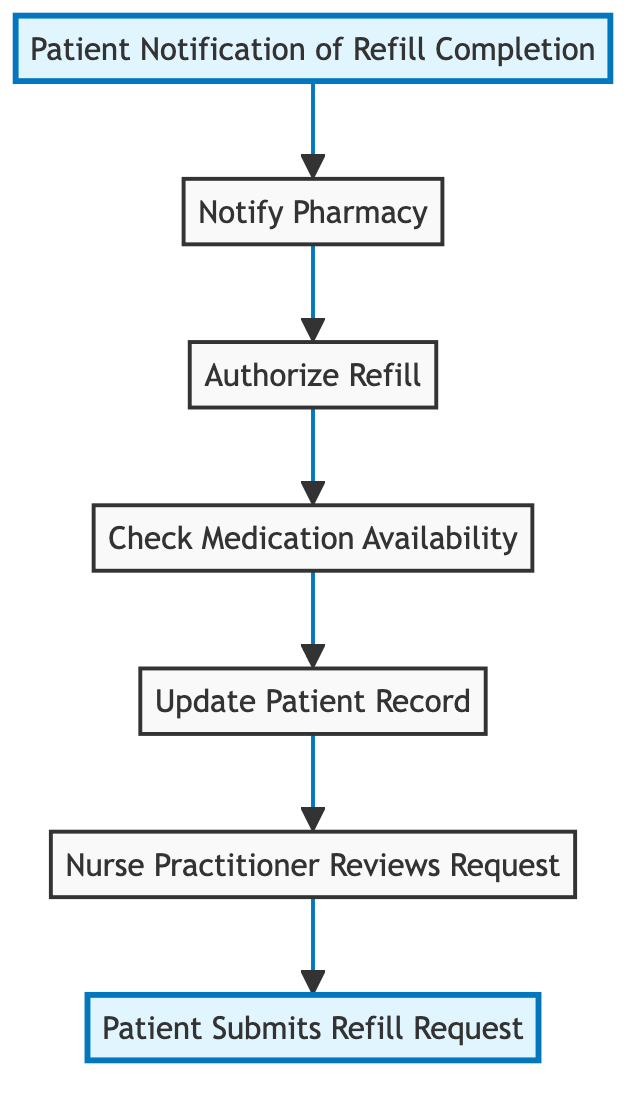What is the first step in the process? The first step depicted in the diagram is "Patient Submits Refill Request." This is shown at the bottom of the flow chart, indicating it is where the process starts.
Answer: Patient Submits Refill Request How many nodes are in the diagram? The diagram contains a total of 7 nodes, each representing a step in the medication refill request procedure. These nodes are interconnected, illustrating the flow of the process.
Answer: 7 What comes after "Notify Pharmacy"? The step that follows "Notify Pharmacy" in the flow chart is "Patient Notification of Refill Completion." This step indicates that once the pharmacy is notified, the patient will be informed next.
Answer: Patient Notification of Refill Completion Which step involves checking if medication is in stock? The step that addresses this task is "Check Medication Availability." In the flow of the process, it comes after "Authorize Refill," confirming if the requested medication is available for the patient.
Answer: Check Medication Availability What action is taken by the nurse practitioner after reviewing the refill request? After the nurse practitioner reviews the request, the next action is "Update Patient Record." This indicates that the practitioner proceeds to record details of the refill request into the patient's medical record.
Answer: Update Patient Record What is the relationship between "Authorize Refill" and "Notify Pharmacy"? "Authorize Refill" leads directly to "Notify Pharmacy," meaning that after the nurse practitioner approves the refill, they send the authorization to the pharmacy next in the process.
Answer: Authorize Refill → Notify Pharmacy What is the last node in the process? The last node in the flow chart is "Patient Notification of Refill Completion," which indicates the final step where the patient is informed about the readiness of their medication.
Answer: Patient Notification of Refill Completion 